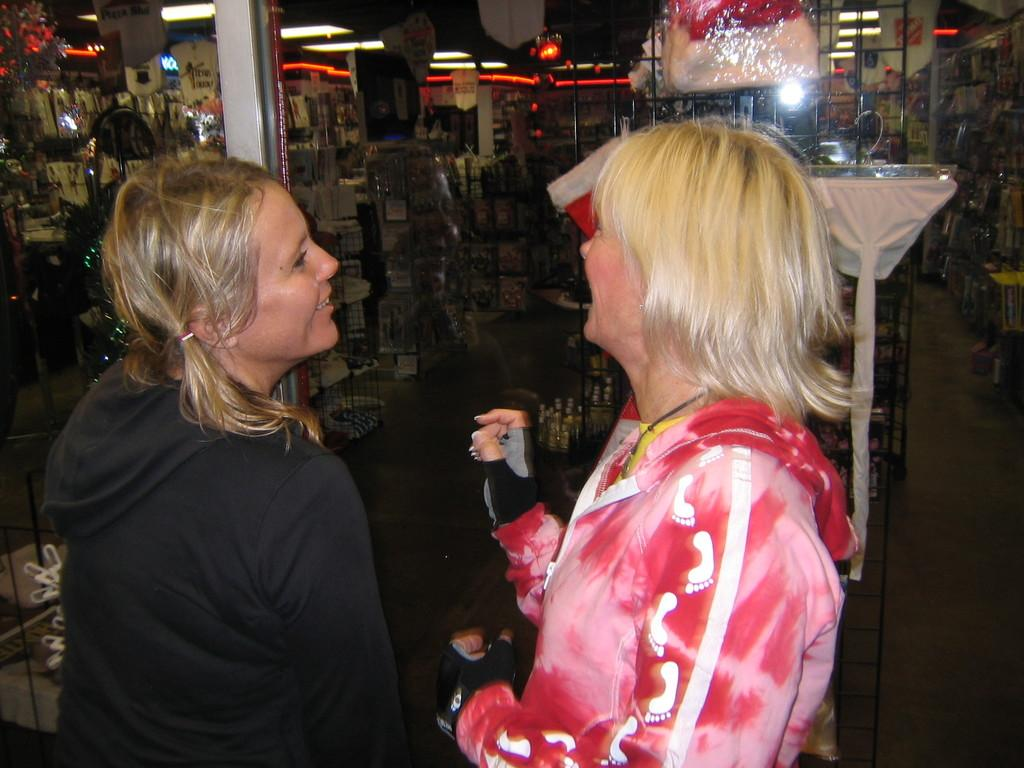How many people are present in the image? There are two ladies standing in the image. What can be seen in the background of the image? There are stalls and shelves with things placed on them in the background of the image. What is visible at the top of the image? There are lights visible at the top of the image. What type of suit is the lady on the left wearing in the image? There is no suit visible in the image; the ladies are not wearing any suits. What invention can be seen in the hands of the lady on the right in the image? There is no invention visible in the hands of the lady on the right or in the image at all. 